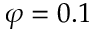<formula> <loc_0><loc_0><loc_500><loc_500>\varphi = 0 . 1</formula> 